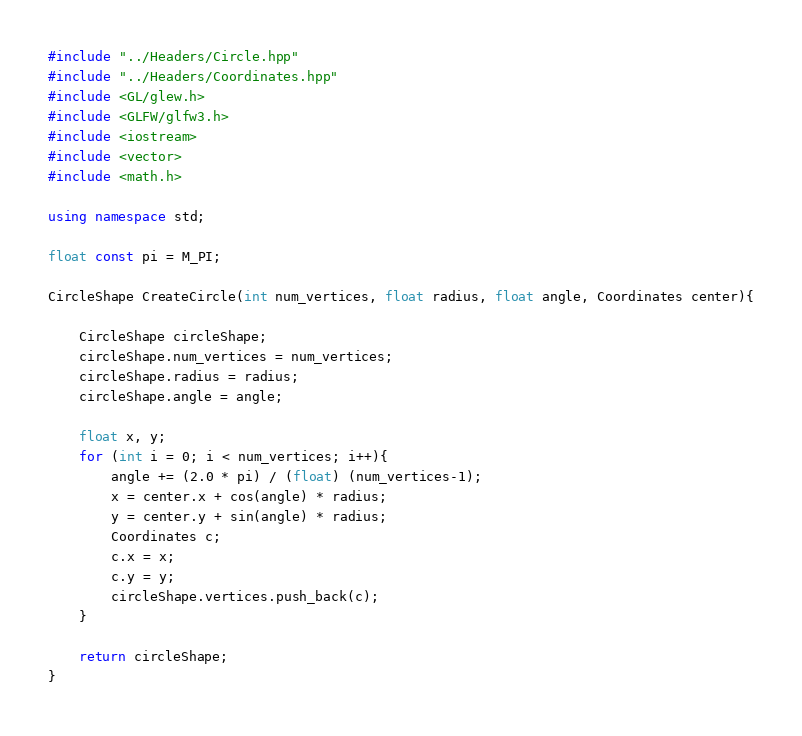<code> <loc_0><loc_0><loc_500><loc_500><_C++_>#include "../Headers/Circle.hpp"
#include "../Headers/Coordinates.hpp"
#include <GL/glew.h>
#include <GLFW/glfw3.h>
#include <iostream>
#include <vector>
#include <math.h>

using namespace std;

float const pi = M_PI;

CircleShape CreateCircle(int num_vertices, float radius, float angle, Coordinates center){

    CircleShape circleShape;
    circleShape.num_vertices = num_vertices;
    circleShape.radius = radius;
    circleShape.angle = angle;

    float x, y;
    for (int i = 0; i < num_vertices; i++){
        angle += (2.0 * pi) / (float) (num_vertices-1);
        x = center.x + cos(angle) * radius;
        y = center.y + sin(angle) * radius;
        Coordinates c;
        c.x = x;
        c.y = y;
        circleShape.vertices.push_back(c);
    }

    return circleShape;
}
</code> 